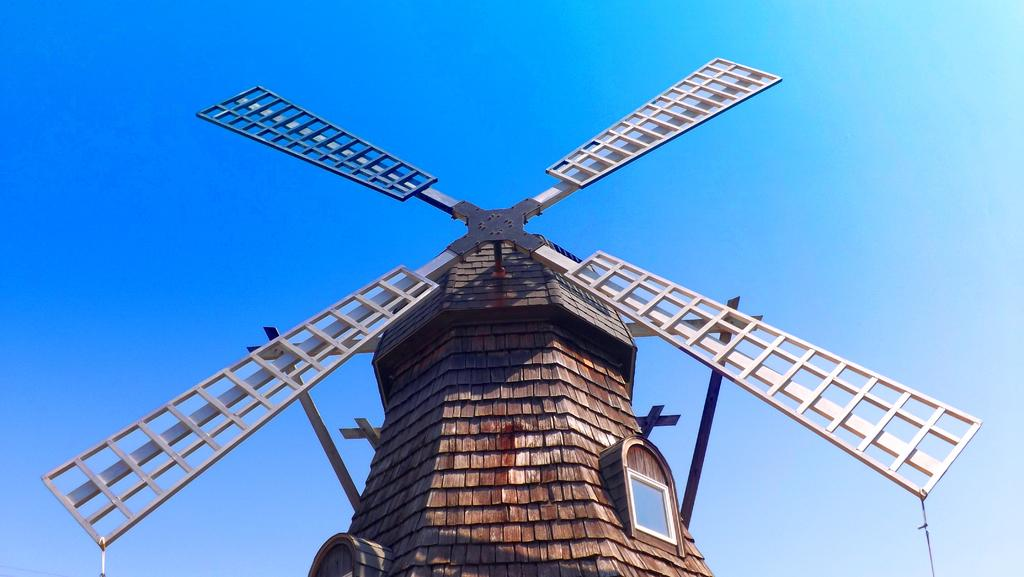What is the main subject in the image? There is a windmill in the image. Where is the windmill located in relation to the image? The windmill is in the front of the image. What can be seen in the background of the image? The sky is visible in the background of the image. What decision does the windmill make in the image? Windmills do not make decisions; they are inanimate objects that are powered by the wind. 